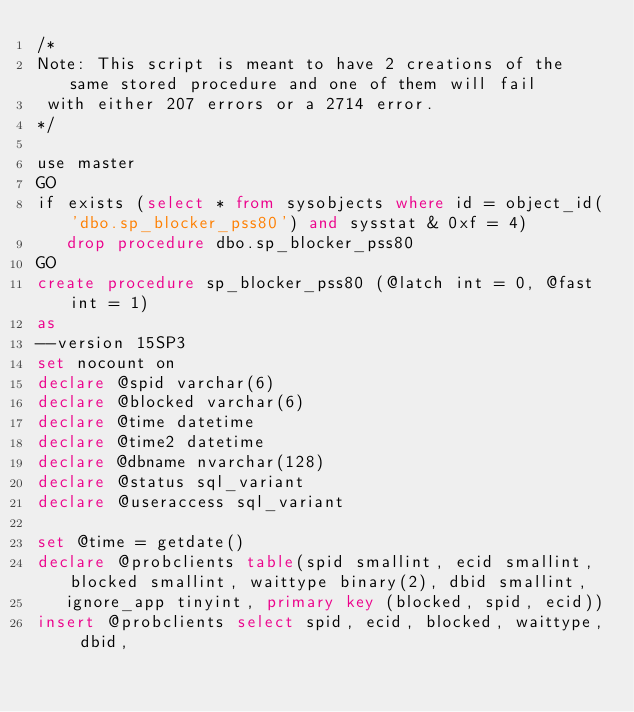<code> <loc_0><loc_0><loc_500><loc_500><_SQL_>/*
Note: This script is meant to have 2 creations of the same stored procedure and one of them will fail
 with either 207 errors or a 2714 error.
*/

use master
GO
if exists (select * from sysobjects where id = object_id('dbo.sp_blocker_pss80') and sysstat & 0xf = 4)
   drop procedure dbo.sp_blocker_pss80
GO
create procedure sp_blocker_pss80 (@latch int = 0, @fast int = 1)
as
--version 15SP3
set nocount on
declare @spid varchar(6)
declare @blocked varchar(6)
declare @time datetime
declare @time2 datetime
declare @dbname nvarchar(128)
declare @status sql_variant
declare @useraccess sql_variant

set @time = getdate()
declare @probclients table(spid smallint, ecid smallint, blocked smallint, waittype binary(2), dbid smallint,
   ignore_app tinyint, primary key (blocked, spid, ecid))
insert @probclients select spid, ecid, blocked, waittype, dbid,</code> 